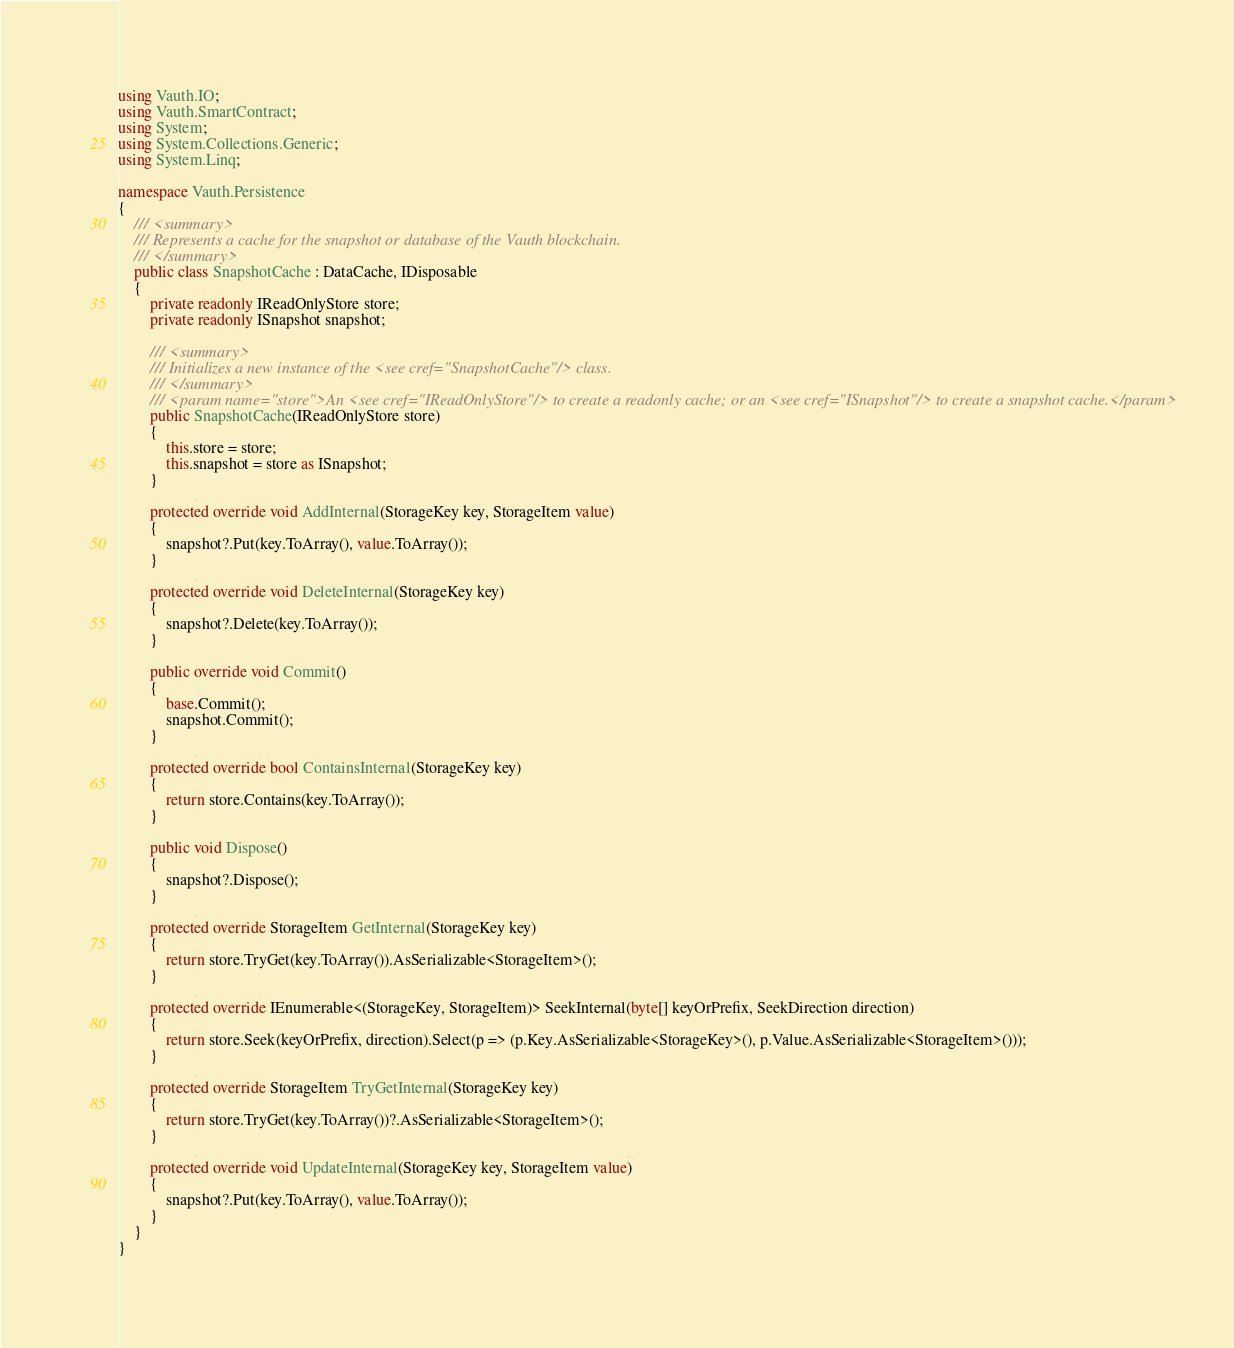Convert code to text. <code><loc_0><loc_0><loc_500><loc_500><_C#_>using Vauth.IO;
using Vauth.SmartContract;
using System;
using System.Collections.Generic;
using System.Linq;

namespace Vauth.Persistence
{
    /// <summary>
    /// Represents a cache for the snapshot or database of the Vauth blockchain.
    /// </summary>
    public class SnapshotCache : DataCache, IDisposable
    {
        private readonly IReadOnlyStore store;
        private readonly ISnapshot snapshot;

        /// <summary>
        /// Initializes a new instance of the <see cref="SnapshotCache"/> class.
        /// </summary>
        /// <param name="store">An <see cref="IReadOnlyStore"/> to create a readonly cache; or an <see cref="ISnapshot"/> to create a snapshot cache.</param>
        public SnapshotCache(IReadOnlyStore store)
        {
            this.store = store;
            this.snapshot = store as ISnapshot;
        }

        protected override void AddInternal(StorageKey key, StorageItem value)
        {
            snapshot?.Put(key.ToArray(), value.ToArray());
        }

        protected override void DeleteInternal(StorageKey key)
        {
            snapshot?.Delete(key.ToArray());
        }

        public override void Commit()
        {
            base.Commit();
            snapshot.Commit();
        }

        protected override bool ContainsInternal(StorageKey key)
        {
            return store.Contains(key.ToArray());
        }

        public void Dispose()
        {
            snapshot?.Dispose();
        }

        protected override StorageItem GetInternal(StorageKey key)
        {
            return store.TryGet(key.ToArray()).AsSerializable<StorageItem>();
        }

        protected override IEnumerable<(StorageKey, StorageItem)> SeekInternal(byte[] keyOrPrefix, SeekDirection direction)
        {
            return store.Seek(keyOrPrefix, direction).Select(p => (p.Key.AsSerializable<StorageKey>(), p.Value.AsSerializable<StorageItem>()));
        }

        protected override StorageItem TryGetInternal(StorageKey key)
        {
            return store.TryGet(key.ToArray())?.AsSerializable<StorageItem>();
        }

        protected override void UpdateInternal(StorageKey key, StorageItem value)
        {
            snapshot?.Put(key.ToArray(), value.ToArray());
        }
    }
}
</code> 